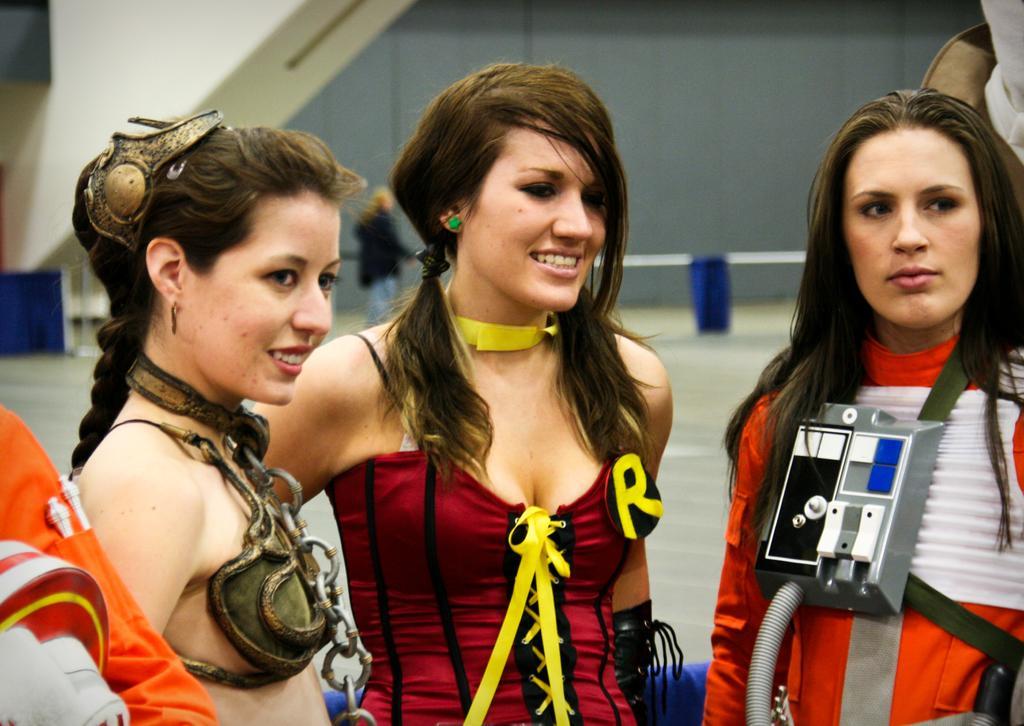Could you give a brief overview of what you see in this image? In the picture we can see three women are standing and two women are smiling and behind them, we can see a building wall and near to it we can see a person standing near the railing pole. 